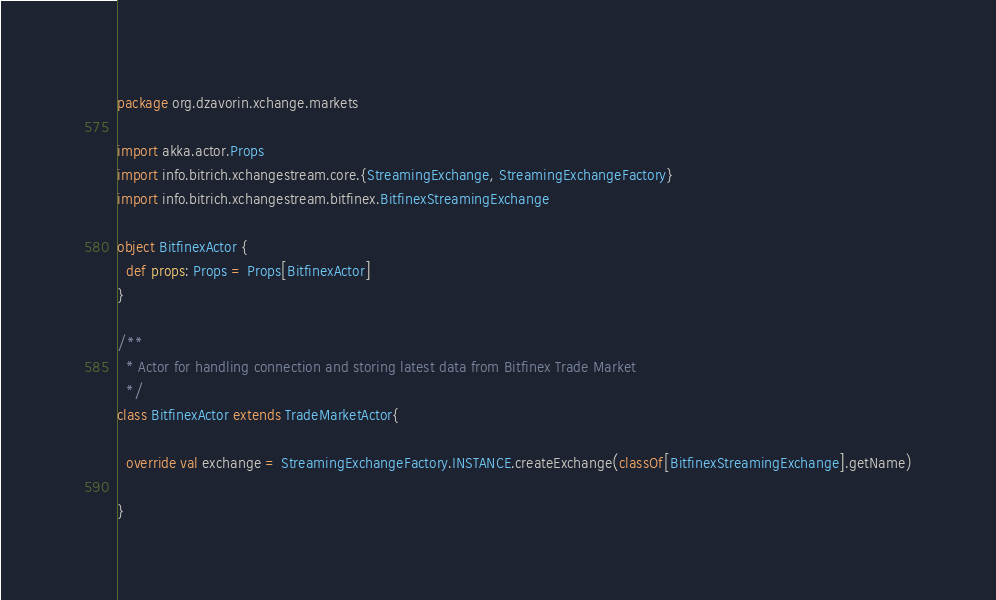<code> <loc_0><loc_0><loc_500><loc_500><_Scala_>package org.dzavorin.xchange.markets

import akka.actor.Props
import info.bitrich.xchangestream.core.{StreamingExchange, StreamingExchangeFactory}
import info.bitrich.xchangestream.bitfinex.BitfinexStreamingExchange

object BitfinexActor {
  def props: Props = Props[BitfinexActor]
}

/**
  * Actor for handling connection and storing latest data from Bitfinex Trade Market
  */
class BitfinexActor extends TradeMarketActor{

  override val exchange = StreamingExchangeFactory.INSTANCE.createExchange(classOf[BitfinexStreamingExchange].getName)

}
</code> 